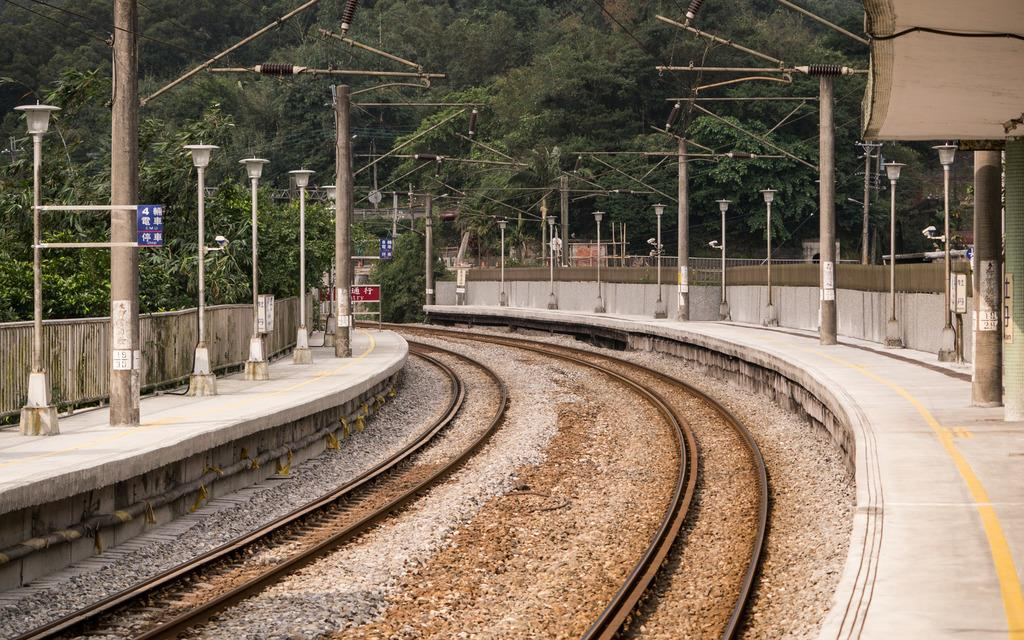What type of transportation infrastructure is shown in the image? There are railway tracks in the image. What else can be seen alongside the railway tracks? Stones, platforms, signboards, and poles are visible in the image. What might be used for providing information or directions in the image? Signboards are present in the image for providing information or directions. What can be seen in the background of the image? There are trees in the background of the image. What type of lace can be seen hanging from the poles in the image? There is no lace present in the image; only railway tracks, stones, platforms, signboards, poles, and trees are visible. 